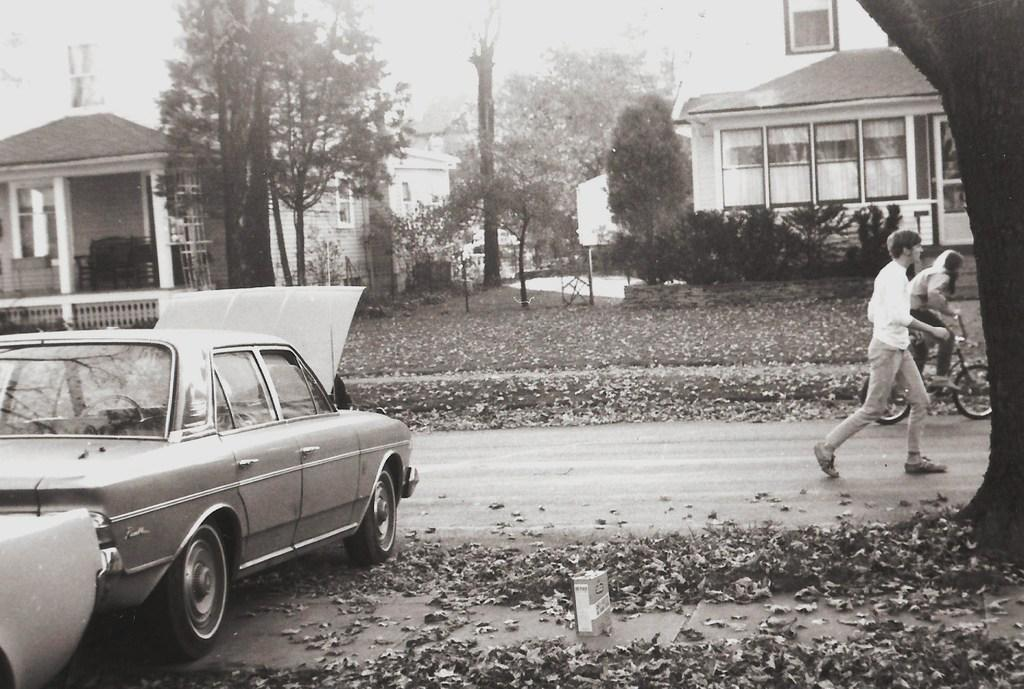What is the man doing on the right side of the image? The man is walking on the right side of the image. What is the lady doing on the right side of the image? The lady is riding a bicycle on the right side of the image. What can be seen on the left side of the image? There is a car on the left side of the image. What is visible in the background of the image? There are trees and buildings in the background of the image. Can you tell me how many grapes are on the observation deck in the image? There is no observation deck or grapes present in the image. What type of island can be seen in the background of the image? There is no island visible in the background of the image; it features trees and buildings. 